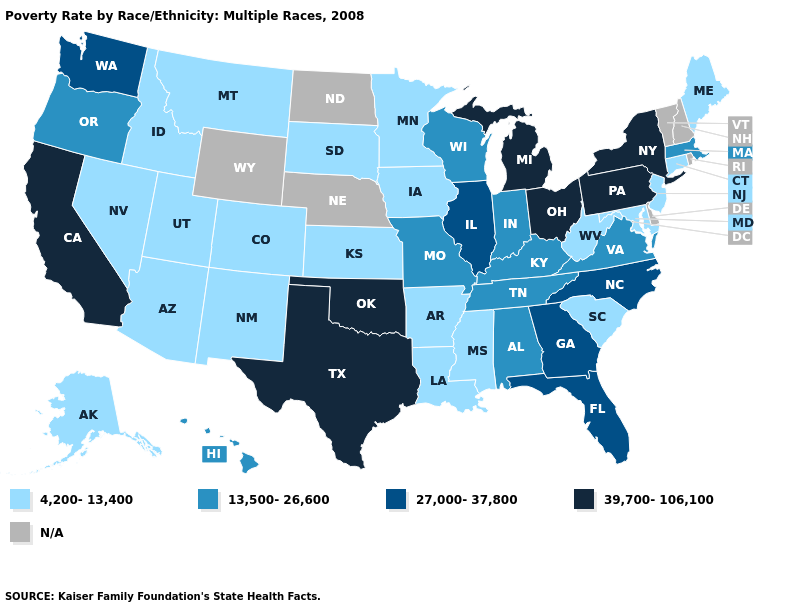Does the first symbol in the legend represent the smallest category?
Give a very brief answer. Yes. What is the value of North Dakota?
Answer briefly. N/A. Among the states that border Wyoming , which have the lowest value?
Write a very short answer. Colorado, Idaho, Montana, South Dakota, Utah. Name the states that have a value in the range 39,700-106,100?
Concise answer only. California, Michigan, New York, Ohio, Oklahoma, Pennsylvania, Texas. What is the value of New Mexico?
Write a very short answer. 4,200-13,400. Name the states that have a value in the range 39,700-106,100?
Short answer required. California, Michigan, New York, Ohio, Oklahoma, Pennsylvania, Texas. What is the highest value in the MidWest ?
Be succinct. 39,700-106,100. Name the states that have a value in the range N/A?
Quick response, please. Delaware, Nebraska, New Hampshire, North Dakota, Rhode Island, Vermont, Wyoming. Does New York have the highest value in the USA?
Write a very short answer. Yes. Does Connecticut have the lowest value in the Northeast?
Answer briefly. Yes. Among the states that border Oregon , does Washington have the lowest value?
Quick response, please. No. What is the highest value in the USA?
Short answer required. 39,700-106,100. How many symbols are there in the legend?
Keep it brief. 5. What is the lowest value in the USA?
Quick response, please. 4,200-13,400. Name the states that have a value in the range 13,500-26,600?
Be succinct. Alabama, Hawaii, Indiana, Kentucky, Massachusetts, Missouri, Oregon, Tennessee, Virginia, Wisconsin. 